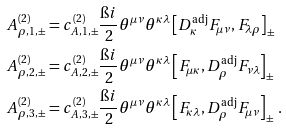<formula> <loc_0><loc_0><loc_500><loc_500>A ^ { ( 2 ) } _ { \rho , 1 , \pm } & = c ^ { ( 2 ) } _ { A , 1 , \pm } \frac { \i i } { 2 } \theta ^ { \mu \nu } \theta ^ { \kappa \lambda } \left [ D ^ { \text {adj} } _ { \kappa } F _ { \mu \nu } , F _ { \lambda \rho } \right ] _ { \pm } \\ A ^ { ( 2 ) } _ { \rho , 2 , \pm } & = c ^ { ( 2 ) } _ { A , 2 , \pm } \frac { \i i } { 2 } \theta ^ { \mu \nu } \theta ^ { \kappa \lambda } \left [ F _ { \mu \kappa } , D ^ { \text {adj} } _ { \rho } F _ { \nu \lambda } \right ] _ { \pm } \\ A ^ { ( 2 ) } _ { \rho , 3 , \pm } & = c ^ { ( 2 ) } _ { A , 3 , \pm } \frac { \i i } { 2 } \theta ^ { \mu \nu } \theta ^ { \kappa \lambda } \left [ F _ { \kappa \lambda } , D ^ { \text {adj} } _ { \rho } F _ { \mu \nu } \right ] _ { \pm } \, .</formula> 